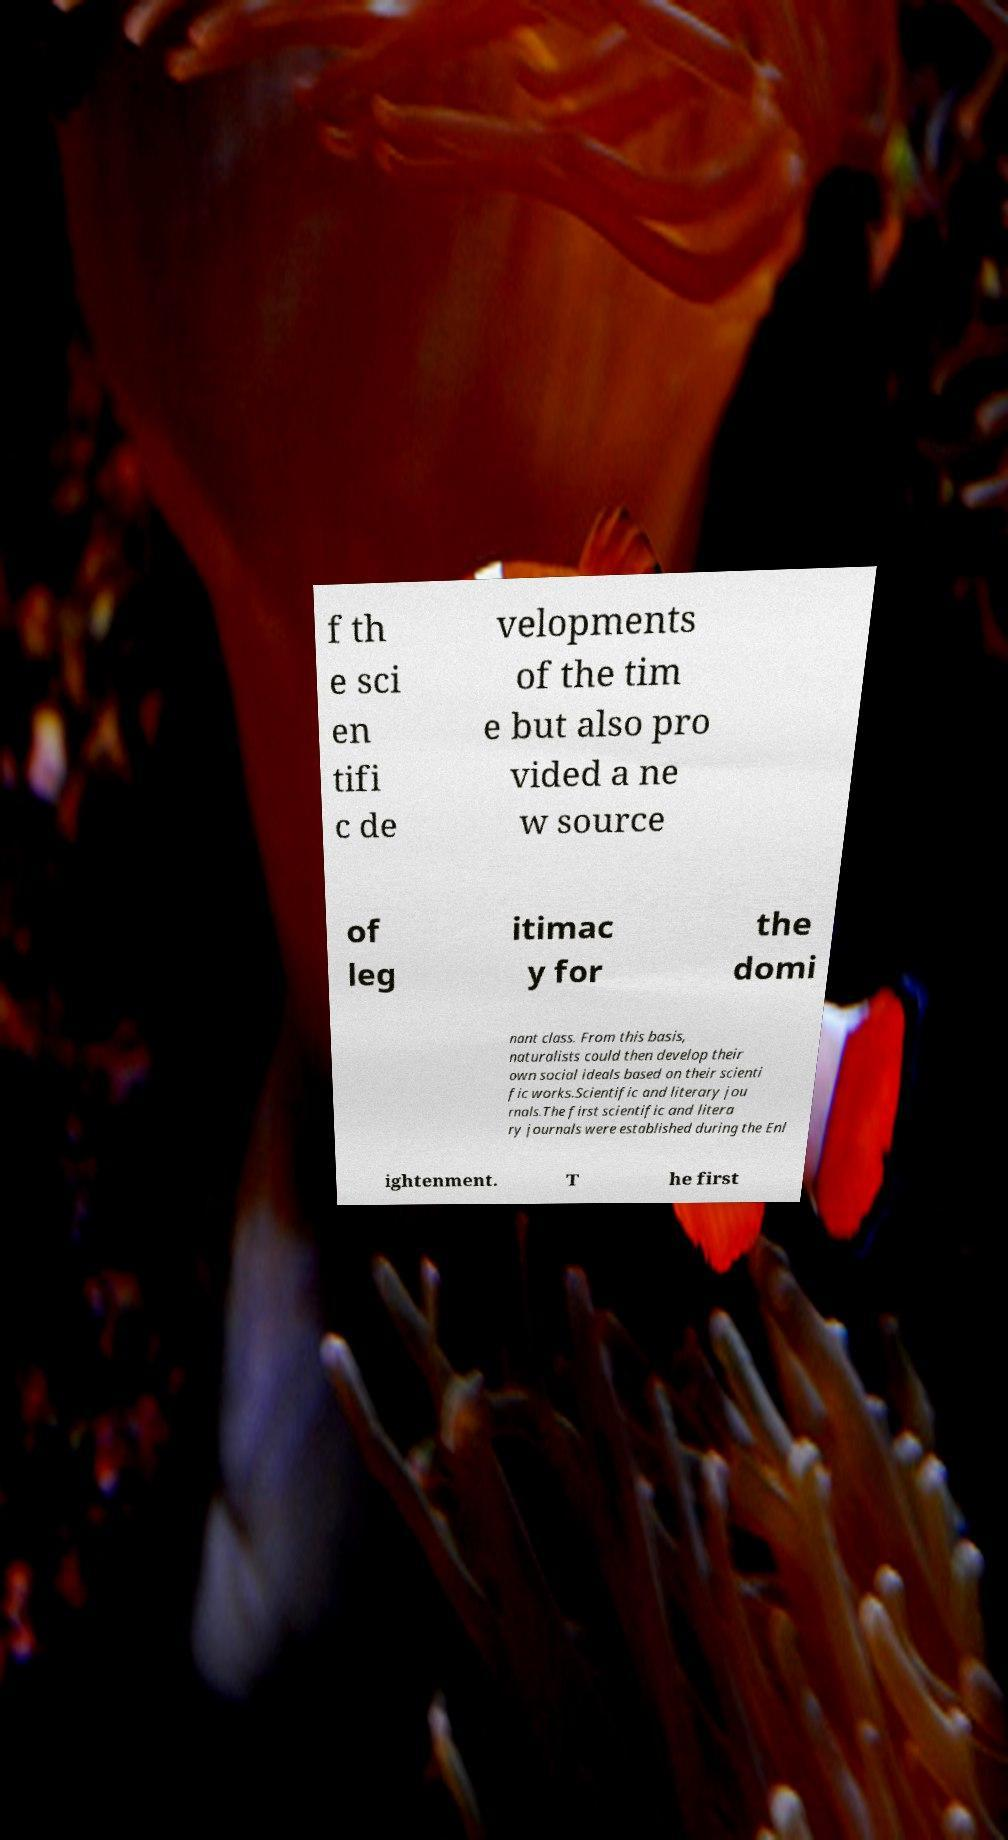What messages or text are displayed in this image? I need them in a readable, typed format. f th e sci en tifi c de velopments of the tim e but also pro vided a ne w source of leg itimac y for the domi nant class. From this basis, naturalists could then develop their own social ideals based on their scienti fic works.Scientific and literary jou rnals.The first scientific and litera ry journals were established during the Enl ightenment. T he first 